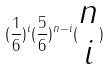<formula> <loc_0><loc_0><loc_500><loc_500>( \frac { 1 } { 6 } ) ^ { i } ( \frac { 5 } { 6 } ) ^ { n - i } ( \begin{matrix} n \\ i \end{matrix} )</formula> 